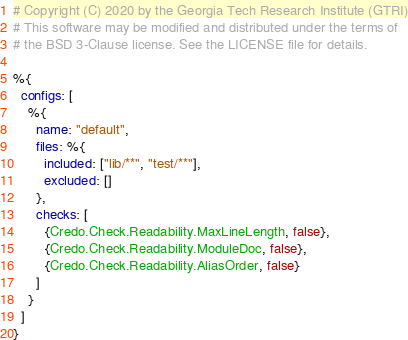<code> <loc_0><loc_0><loc_500><loc_500><_Elixir_># Copyright (C) 2020 by the Georgia Tech Research Institute (GTRI)
# This software may be modified and distributed under the terms of
# the BSD 3-Clause license. See the LICENSE file for details.

%{
  configs: [
    %{
      name: "default",
      files: %{
        included: ["lib/**", "test/**"],
        excluded: []
      },
      checks: [
        {Credo.Check.Readability.MaxLineLength, false},
        {Credo.Check.Readability.ModuleDoc, false},
        {Credo.Check.Readability.AliasOrder, false}
      ]
    }
  ]
}
</code> 